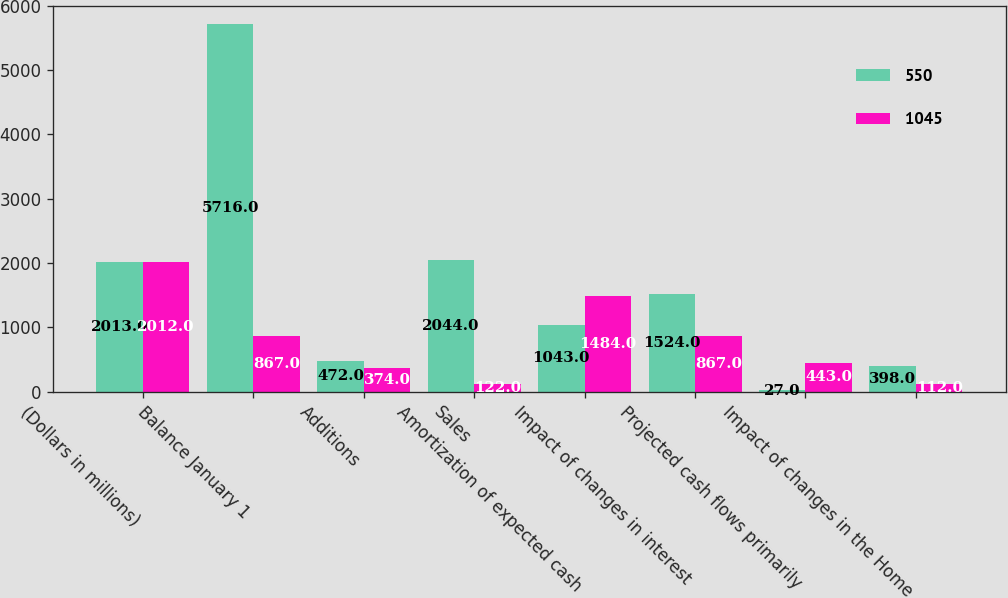Convert chart to OTSL. <chart><loc_0><loc_0><loc_500><loc_500><stacked_bar_chart><ecel><fcel>(Dollars in millions)<fcel>Balance January 1<fcel>Additions<fcel>Sales<fcel>Amortization of expected cash<fcel>Impact of changes in interest<fcel>Projected cash flows primarily<fcel>Impact of changes in the Home<nl><fcel>550<fcel>2013<fcel>5716<fcel>472<fcel>2044<fcel>1043<fcel>1524<fcel>27<fcel>398<nl><fcel>1045<fcel>2012<fcel>867<fcel>374<fcel>122<fcel>1484<fcel>867<fcel>443<fcel>112<nl></chart> 